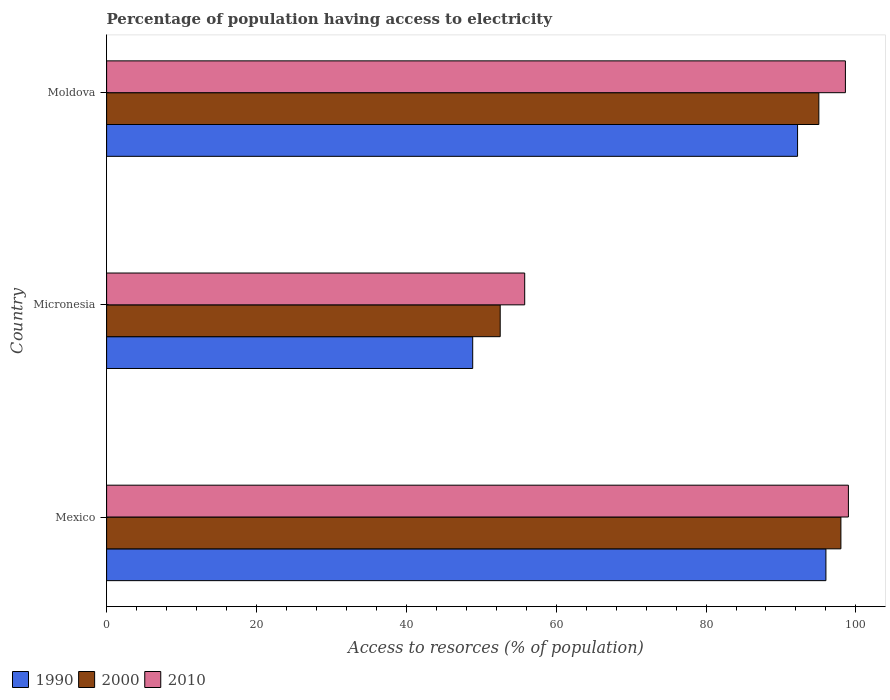How many different coloured bars are there?
Give a very brief answer. 3. Are the number of bars per tick equal to the number of legend labels?
Provide a succinct answer. Yes. What is the label of the 2nd group of bars from the top?
Offer a very short reply. Micronesia. In how many cases, is the number of bars for a given country not equal to the number of legend labels?
Your answer should be very brief. 0. What is the percentage of population having access to electricity in 1990 in Mexico?
Your answer should be compact. 96. Across all countries, what is the maximum percentage of population having access to electricity in 2010?
Give a very brief answer. 99. Across all countries, what is the minimum percentage of population having access to electricity in 1990?
Give a very brief answer. 48.86. In which country was the percentage of population having access to electricity in 2010 maximum?
Ensure brevity in your answer.  Mexico. In which country was the percentage of population having access to electricity in 2000 minimum?
Offer a very short reply. Micronesia. What is the total percentage of population having access to electricity in 1990 in the graph?
Offer a very short reply. 237.07. What is the difference between the percentage of population having access to electricity in 2010 in Mexico and that in Moldova?
Offer a very short reply. 0.4. What is the difference between the percentage of population having access to electricity in 2000 in Micronesia and the percentage of population having access to electricity in 2010 in Mexico?
Provide a succinct answer. -46.47. What is the average percentage of population having access to electricity in 2010 per country?
Keep it short and to the point. 84.47. What is the difference between the percentage of population having access to electricity in 1990 and percentage of population having access to electricity in 2010 in Micronesia?
Your answer should be compact. -6.94. What is the ratio of the percentage of population having access to electricity in 2010 in Mexico to that in Micronesia?
Ensure brevity in your answer.  1.77. Is the percentage of population having access to electricity in 1990 in Mexico less than that in Moldova?
Ensure brevity in your answer.  No. What is the difference between the highest and the second highest percentage of population having access to electricity in 1990?
Offer a terse response. 3.78. What is the difference between the highest and the lowest percentage of population having access to electricity in 2010?
Offer a terse response. 43.2. In how many countries, is the percentage of population having access to electricity in 2010 greater than the average percentage of population having access to electricity in 2010 taken over all countries?
Ensure brevity in your answer.  2. What does the 1st bar from the bottom in Micronesia represents?
Your answer should be compact. 1990. How many bars are there?
Your response must be concise. 9. How many countries are there in the graph?
Provide a short and direct response. 3. Where does the legend appear in the graph?
Your answer should be compact. Bottom left. How many legend labels are there?
Your response must be concise. 3. What is the title of the graph?
Provide a short and direct response. Percentage of population having access to electricity. Does "1966" appear as one of the legend labels in the graph?
Keep it short and to the point. No. What is the label or title of the X-axis?
Provide a short and direct response. Access to resorces (% of population). What is the label or title of the Y-axis?
Provide a succinct answer. Country. What is the Access to resorces (% of population) in 1990 in Mexico?
Offer a very short reply. 96. What is the Access to resorces (% of population) in 1990 in Micronesia?
Your answer should be very brief. 48.86. What is the Access to resorces (% of population) in 2000 in Micronesia?
Your answer should be very brief. 52.53. What is the Access to resorces (% of population) in 2010 in Micronesia?
Ensure brevity in your answer.  55.8. What is the Access to resorces (% of population) of 1990 in Moldova?
Provide a succinct answer. 92.22. What is the Access to resorces (% of population) of 2000 in Moldova?
Your answer should be compact. 95.06. What is the Access to resorces (% of population) of 2010 in Moldova?
Give a very brief answer. 98.6. Across all countries, what is the maximum Access to resorces (% of population) in 1990?
Ensure brevity in your answer.  96. Across all countries, what is the maximum Access to resorces (% of population) of 2000?
Provide a succinct answer. 98. Across all countries, what is the minimum Access to resorces (% of population) in 1990?
Provide a succinct answer. 48.86. Across all countries, what is the minimum Access to resorces (% of population) of 2000?
Provide a succinct answer. 52.53. Across all countries, what is the minimum Access to resorces (% of population) of 2010?
Ensure brevity in your answer.  55.8. What is the total Access to resorces (% of population) of 1990 in the graph?
Your answer should be very brief. 237.07. What is the total Access to resorces (% of population) of 2000 in the graph?
Make the answer very short. 245.59. What is the total Access to resorces (% of population) in 2010 in the graph?
Your answer should be very brief. 253.4. What is the difference between the Access to resorces (% of population) in 1990 in Mexico and that in Micronesia?
Offer a very short reply. 47.14. What is the difference between the Access to resorces (% of population) of 2000 in Mexico and that in Micronesia?
Offer a very short reply. 45.47. What is the difference between the Access to resorces (% of population) in 2010 in Mexico and that in Micronesia?
Provide a succinct answer. 43.2. What is the difference between the Access to resorces (% of population) of 1990 in Mexico and that in Moldova?
Provide a short and direct response. 3.78. What is the difference between the Access to resorces (% of population) in 2000 in Mexico and that in Moldova?
Ensure brevity in your answer.  2.94. What is the difference between the Access to resorces (% of population) of 1990 in Micronesia and that in Moldova?
Keep it short and to the point. -43.36. What is the difference between the Access to resorces (% of population) of 2000 in Micronesia and that in Moldova?
Give a very brief answer. -42.53. What is the difference between the Access to resorces (% of population) in 2010 in Micronesia and that in Moldova?
Provide a short and direct response. -42.8. What is the difference between the Access to resorces (% of population) of 1990 in Mexico and the Access to resorces (% of population) of 2000 in Micronesia?
Your answer should be compact. 43.47. What is the difference between the Access to resorces (% of population) of 1990 in Mexico and the Access to resorces (% of population) of 2010 in Micronesia?
Your response must be concise. 40.2. What is the difference between the Access to resorces (% of population) of 2000 in Mexico and the Access to resorces (% of population) of 2010 in Micronesia?
Your answer should be very brief. 42.2. What is the difference between the Access to resorces (% of population) of 1990 in Mexico and the Access to resorces (% of population) of 2000 in Moldova?
Keep it short and to the point. 0.94. What is the difference between the Access to resorces (% of population) in 2000 in Mexico and the Access to resorces (% of population) in 2010 in Moldova?
Ensure brevity in your answer.  -0.6. What is the difference between the Access to resorces (% of population) in 1990 in Micronesia and the Access to resorces (% of population) in 2000 in Moldova?
Offer a terse response. -46.2. What is the difference between the Access to resorces (% of population) of 1990 in Micronesia and the Access to resorces (% of population) of 2010 in Moldova?
Provide a short and direct response. -49.74. What is the difference between the Access to resorces (% of population) of 2000 in Micronesia and the Access to resorces (% of population) of 2010 in Moldova?
Offer a terse response. -46.07. What is the average Access to resorces (% of population) in 1990 per country?
Keep it short and to the point. 79.02. What is the average Access to resorces (% of population) in 2000 per country?
Ensure brevity in your answer.  81.86. What is the average Access to resorces (% of population) of 2010 per country?
Make the answer very short. 84.47. What is the difference between the Access to resorces (% of population) of 1990 and Access to resorces (% of population) of 2000 in Mexico?
Offer a terse response. -2. What is the difference between the Access to resorces (% of population) in 1990 and Access to resorces (% of population) in 2010 in Mexico?
Keep it short and to the point. -3. What is the difference between the Access to resorces (% of population) of 1990 and Access to resorces (% of population) of 2000 in Micronesia?
Ensure brevity in your answer.  -3.67. What is the difference between the Access to resorces (% of population) in 1990 and Access to resorces (% of population) in 2010 in Micronesia?
Keep it short and to the point. -6.94. What is the difference between the Access to resorces (% of population) of 2000 and Access to resorces (% of population) of 2010 in Micronesia?
Offer a terse response. -3.27. What is the difference between the Access to resorces (% of population) of 1990 and Access to resorces (% of population) of 2000 in Moldova?
Your answer should be very brief. -2.84. What is the difference between the Access to resorces (% of population) in 1990 and Access to resorces (% of population) in 2010 in Moldova?
Ensure brevity in your answer.  -6.38. What is the difference between the Access to resorces (% of population) of 2000 and Access to resorces (% of population) of 2010 in Moldova?
Your response must be concise. -3.54. What is the ratio of the Access to resorces (% of population) in 1990 in Mexico to that in Micronesia?
Your response must be concise. 1.96. What is the ratio of the Access to resorces (% of population) of 2000 in Mexico to that in Micronesia?
Provide a short and direct response. 1.87. What is the ratio of the Access to resorces (% of population) in 2010 in Mexico to that in Micronesia?
Your answer should be compact. 1.77. What is the ratio of the Access to resorces (% of population) of 1990 in Mexico to that in Moldova?
Your answer should be very brief. 1.04. What is the ratio of the Access to resorces (% of population) of 2000 in Mexico to that in Moldova?
Your answer should be compact. 1.03. What is the ratio of the Access to resorces (% of population) in 2010 in Mexico to that in Moldova?
Your answer should be very brief. 1. What is the ratio of the Access to resorces (% of population) of 1990 in Micronesia to that in Moldova?
Ensure brevity in your answer.  0.53. What is the ratio of the Access to resorces (% of population) of 2000 in Micronesia to that in Moldova?
Your answer should be very brief. 0.55. What is the ratio of the Access to resorces (% of population) of 2010 in Micronesia to that in Moldova?
Provide a short and direct response. 0.57. What is the difference between the highest and the second highest Access to resorces (% of population) of 1990?
Give a very brief answer. 3.78. What is the difference between the highest and the second highest Access to resorces (% of population) in 2000?
Keep it short and to the point. 2.94. What is the difference between the highest and the second highest Access to resorces (% of population) in 2010?
Offer a very short reply. 0.4. What is the difference between the highest and the lowest Access to resorces (% of population) in 1990?
Your response must be concise. 47.14. What is the difference between the highest and the lowest Access to resorces (% of population) of 2000?
Keep it short and to the point. 45.47. What is the difference between the highest and the lowest Access to resorces (% of population) of 2010?
Provide a short and direct response. 43.2. 